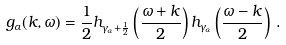Convert formula to latex. <formula><loc_0><loc_0><loc_500><loc_500>g _ { \alpha } ( k , \omega ) = \frac { 1 } { 2 } h _ { \gamma _ { \alpha } + \frac { 1 } { 2 } } \left ( \frac { \omega + k } { 2 } \right ) h _ { \gamma _ { \alpha } } \left ( \frac { \omega - k } { 2 } \right ) \, .</formula> 